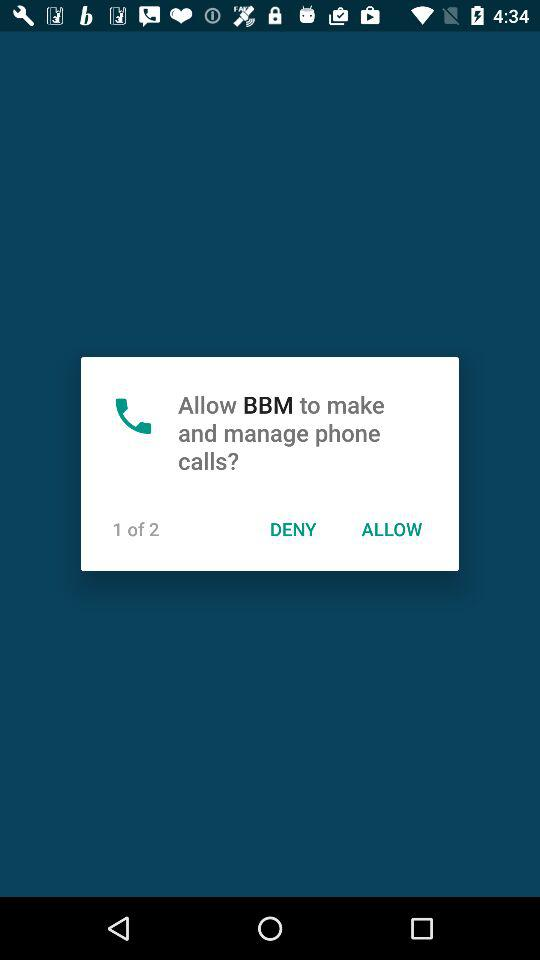What is the user's phone number?
When the provided information is insufficient, respond with <no answer>. <no answer> 